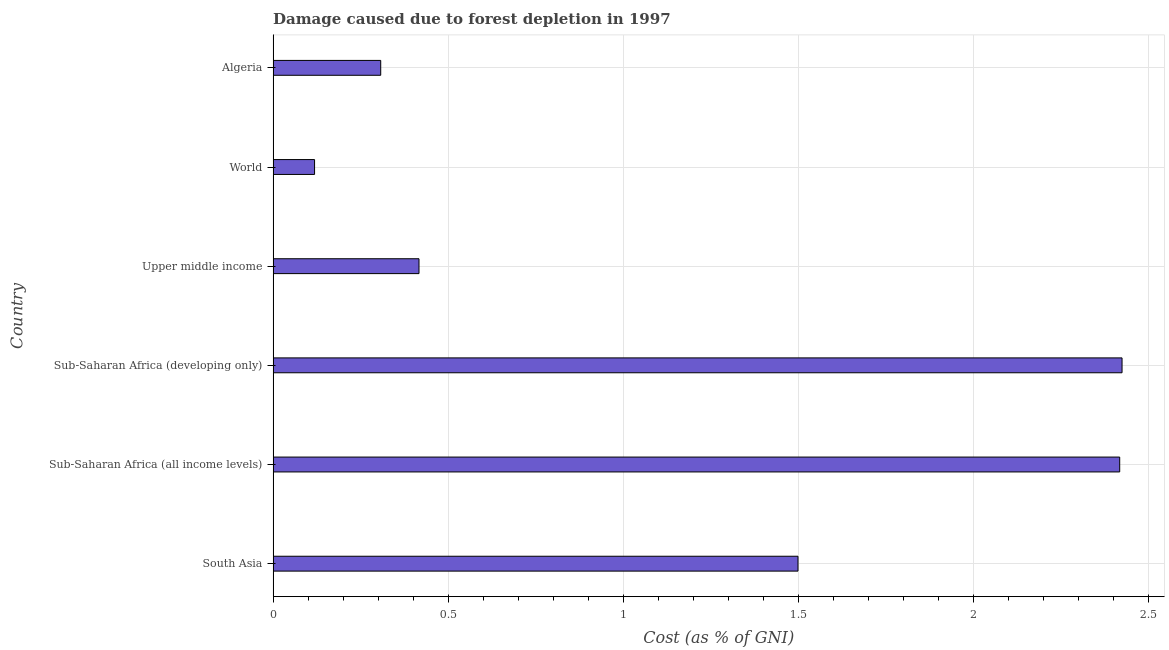What is the title of the graph?
Offer a very short reply. Damage caused due to forest depletion in 1997. What is the label or title of the X-axis?
Give a very brief answer. Cost (as % of GNI). What is the damage caused due to forest depletion in Sub-Saharan Africa (all income levels)?
Provide a succinct answer. 2.42. Across all countries, what is the maximum damage caused due to forest depletion?
Your response must be concise. 2.42. Across all countries, what is the minimum damage caused due to forest depletion?
Offer a terse response. 0.12. In which country was the damage caused due to forest depletion maximum?
Your answer should be very brief. Sub-Saharan Africa (developing only). What is the sum of the damage caused due to forest depletion?
Your answer should be compact. 7.19. What is the difference between the damage caused due to forest depletion in South Asia and Upper middle income?
Provide a short and direct response. 1.08. What is the average damage caused due to forest depletion per country?
Ensure brevity in your answer.  1.2. What is the median damage caused due to forest depletion?
Provide a short and direct response. 0.96. In how many countries, is the damage caused due to forest depletion greater than 0.6 %?
Offer a terse response. 3. What is the ratio of the damage caused due to forest depletion in Algeria to that in World?
Ensure brevity in your answer.  2.6. Is the damage caused due to forest depletion in Algeria less than that in Upper middle income?
Your answer should be compact. Yes. Is the difference between the damage caused due to forest depletion in Sub-Saharan Africa (developing only) and Upper middle income greater than the difference between any two countries?
Your answer should be compact. No. What is the difference between the highest and the second highest damage caused due to forest depletion?
Give a very brief answer. 0.01. What is the difference between the highest and the lowest damage caused due to forest depletion?
Keep it short and to the point. 2.31. How many bars are there?
Offer a very short reply. 6. Are all the bars in the graph horizontal?
Give a very brief answer. Yes. How many countries are there in the graph?
Provide a short and direct response. 6. Are the values on the major ticks of X-axis written in scientific E-notation?
Offer a very short reply. No. What is the Cost (as % of GNI) in South Asia?
Keep it short and to the point. 1.5. What is the Cost (as % of GNI) of Sub-Saharan Africa (all income levels)?
Give a very brief answer. 2.42. What is the Cost (as % of GNI) in Sub-Saharan Africa (developing only)?
Offer a terse response. 2.42. What is the Cost (as % of GNI) of Upper middle income?
Your answer should be compact. 0.42. What is the Cost (as % of GNI) of World?
Ensure brevity in your answer.  0.12. What is the Cost (as % of GNI) in Algeria?
Give a very brief answer. 0.31. What is the difference between the Cost (as % of GNI) in South Asia and Sub-Saharan Africa (all income levels)?
Ensure brevity in your answer.  -0.92. What is the difference between the Cost (as % of GNI) in South Asia and Sub-Saharan Africa (developing only)?
Provide a short and direct response. -0.93. What is the difference between the Cost (as % of GNI) in South Asia and Upper middle income?
Ensure brevity in your answer.  1.08. What is the difference between the Cost (as % of GNI) in South Asia and World?
Give a very brief answer. 1.38. What is the difference between the Cost (as % of GNI) in South Asia and Algeria?
Your response must be concise. 1.19. What is the difference between the Cost (as % of GNI) in Sub-Saharan Africa (all income levels) and Sub-Saharan Africa (developing only)?
Offer a very short reply. -0.01. What is the difference between the Cost (as % of GNI) in Sub-Saharan Africa (all income levels) and Upper middle income?
Offer a very short reply. 2. What is the difference between the Cost (as % of GNI) in Sub-Saharan Africa (all income levels) and World?
Your response must be concise. 2.3. What is the difference between the Cost (as % of GNI) in Sub-Saharan Africa (all income levels) and Algeria?
Keep it short and to the point. 2.11. What is the difference between the Cost (as % of GNI) in Sub-Saharan Africa (developing only) and Upper middle income?
Provide a succinct answer. 2.01. What is the difference between the Cost (as % of GNI) in Sub-Saharan Africa (developing only) and World?
Make the answer very short. 2.31. What is the difference between the Cost (as % of GNI) in Sub-Saharan Africa (developing only) and Algeria?
Keep it short and to the point. 2.12. What is the difference between the Cost (as % of GNI) in Upper middle income and World?
Your answer should be very brief. 0.3. What is the difference between the Cost (as % of GNI) in Upper middle income and Algeria?
Offer a very short reply. 0.11. What is the difference between the Cost (as % of GNI) in World and Algeria?
Ensure brevity in your answer.  -0.19. What is the ratio of the Cost (as % of GNI) in South Asia to that in Sub-Saharan Africa (all income levels)?
Give a very brief answer. 0.62. What is the ratio of the Cost (as % of GNI) in South Asia to that in Sub-Saharan Africa (developing only)?
Keep it short and to the point. 0.62. What is the ratio of the Cost (as % of GNI) in South Asia to that in Upper middle income?
Keep it short and to the point. 3.6. What is the ratio of the Cost (as % of GNI) in South Asia to that in World?
Keep it short and to the point. 12.67. What is the ratio of the Cost (as % of GNI) in South Asia to that in Algeria?
Your answer should be compact. 4.88. What is the ratio of the Cost (as % of GNI) in Sub-Saharan Africa (all income levels) to that in Upper middle income?
Ensure brevity in your answer.  5.8. What is the ratio of the Cost (as % of GNI) in Sub-Saharan Africa (all income levels) to that in World?
Provide a short and direct response. 20.43. What is the ratio of the Cost (as % of GNI) in Sub-Saharan Africa (all income levels) to that in Algeria?
Give a very brief answer. 7.87. What is the ratio of the Cost (as % of GNI) in Sub-Saharan Africa (developing only) to that in Upper middle income?
Your answer should be compact. 5.82. What is the ratio of the Cost (as % of GNI) in Sub-Saharan Africa (developing only) to that in World?
Your answer should be very brief. 20.49. What is the ratio of the Cost (as % of GNI) in Sub-Saharan Africa (developing only) to that in Algeria?
Your answer should be compact. 7.89. What is the ratio of the Cost (as % of GNI) in Upper middle income to that in World?
Provide a short and direct response. 3.52. What is the ratio of the Cost (as % of GNI) in Upper middle income to that in Algeria?
Your answer should be compact. 1.36. What is the ratio of the Cost (as % of GNI) in World to that in Algeria?
Offer a very short reply. 0.39. 